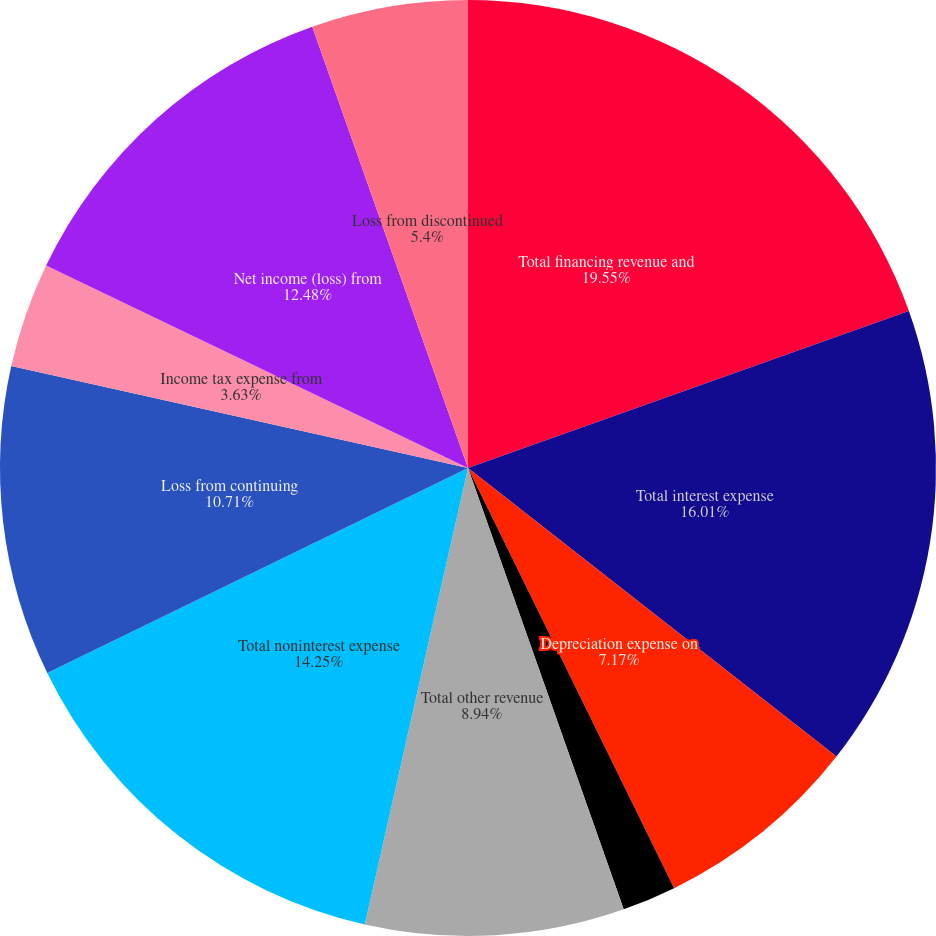Convert chart. <chart><loc_0><loc_0><loc_500><loc_500><pie_chart><fcel>Total financing revenue and<fcel>Total interest expense<fcel>Depreciation expense on<fcel>Gain on extinguishment of debt<fcel>Total other revenue<fcel>Total noninterest expense<fcel>Loss from continuing<fcel>Income tax expense from<fcel>Net income (loss) from<fcel>Loss from discontinued<nl><fcel>19.56%<fcel>16.02%<fcel>7.17%<fcel>1.86%<fcel>8.94%<fcel>14.25%<fcel>10.71%<fcel>3.63%<fcel>12.48%<fcel>5.4%<nl></chart> 